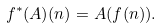<formula> <loc_0><loc_0><loc_500><loc_500>f ^ { * } ( A ) ( n ) = A ( f ( n ) ) .</formula> 